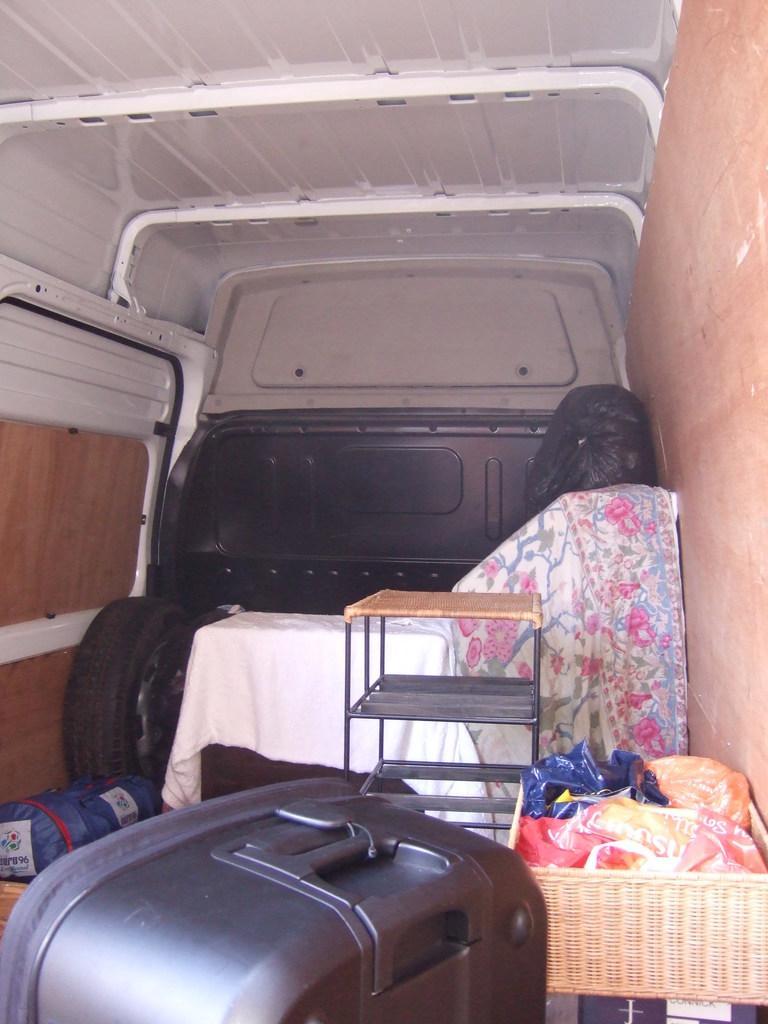In one or two sentences, can you explain what this image depicts? This picture consists of inside view of the vehicle and I can see a luggage bag and table , cloths , baskets, in basket I can see covers and another table and a Tyre visible. 